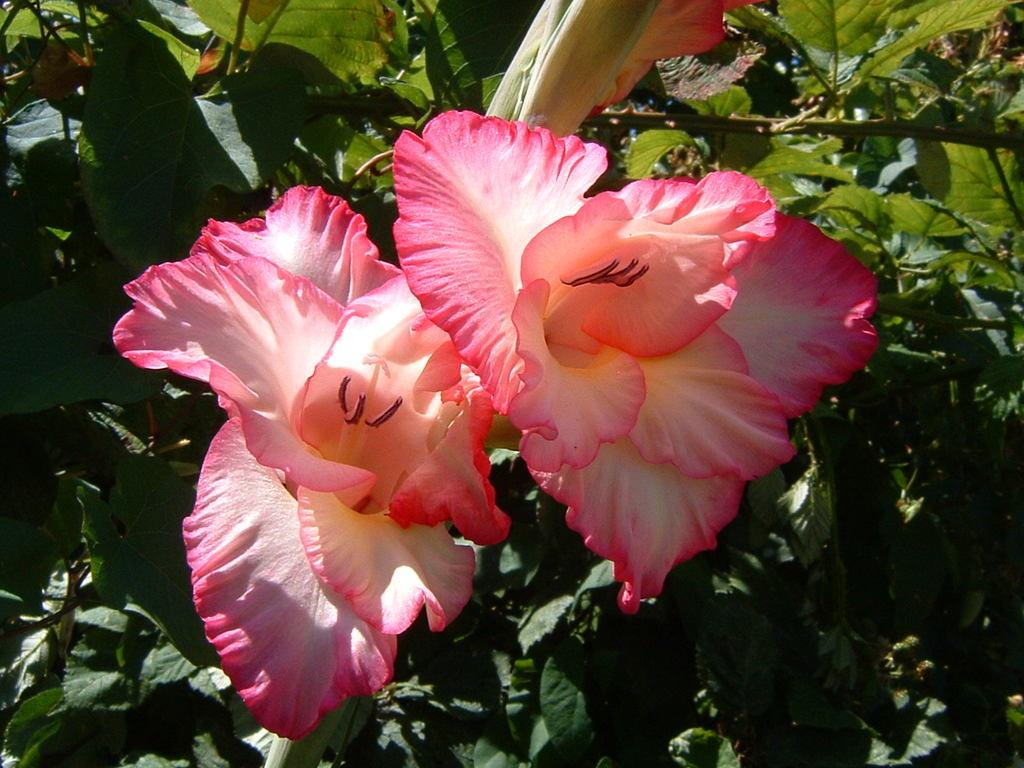Where was the image taken? The image is taken outdoors. What can be seen in the image besides the outdoor setting? There are plants in the image. How many flowers are visible in the image? There are two flowers in the image. What are the colors of the flowers? One flower is pink in color, and the other flower is white in color. Are there any celery or lettuce plants visible in the image? No, there are no celery or lettuce plants visible in the image; only flowers and other plants are present. 